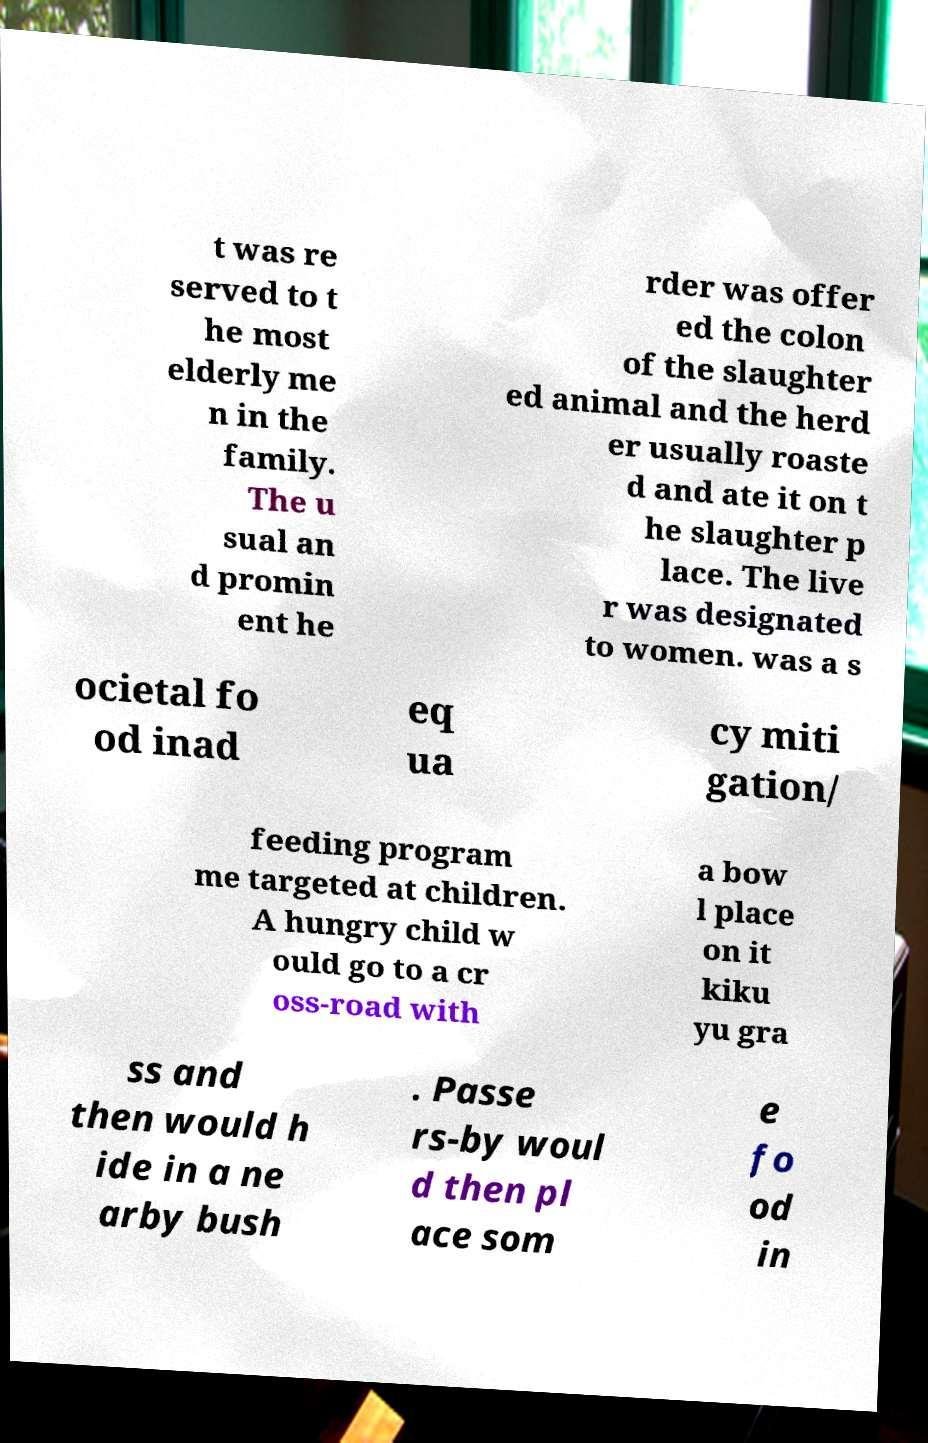Can you read and provide the text displayed in the image?This photo seems to have some interesting text. Can you extract and type it out for me? t was re served to t he most elderly me n in the family. The u sual an d promin ent he rder was offer ed the colon of the slaughter ed animal and the herd er usually roaste d and ate it on t he slaughter p lace. The live r was designated to women. was a s ocietal fo od inad eq ua cy miti gation/ feeding program me targeted at children. A hungry child w ould go to a cr oss-road with a bow l place on it kiku yu gra ss and then would h ide in a ne arby bush . Passe rs-by woul d then pl ace som e fo od in 